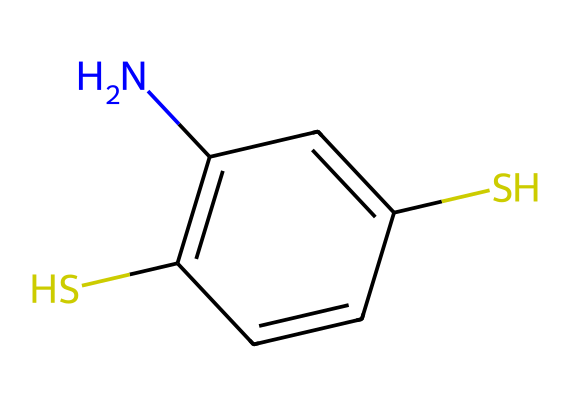what is the molecular formula of this compound? To determine the molecular formula, we count the number of each type of atom in the SMILES representation. In this case, there are 10 carbon (C) atoms, 9 hydrogen (H) atoms, 2 sulfur (S) atoms, and 1 nitrogen (N) atom. Therefore, the molecular formula is C10H9N2S2.
Answer: C10H9N2S2 how many sulfur atoms are present in this structure? By inspecting the SMILES notation, we see two instances of "S," which indicates the presence of two sulfur atoms in the structure. Thus, there are 2 sulfur atoms.
Answer: 2 what type of compounds are represented by this structure? The presence of sulfur atoms, along with the cyclic nature and specific functional groups in the structure, indicates that this compound belongs to the class of sulfur compounds.
Answer: sulfur compounds which atoms in the structure indicate the presence of a functional group? The nitrogen atom (N) in the structure is indicative of an amine functional group. In addition, the sulfur atoms (S) contribute to the properties associated with thiols or sulfides. Thus, the presence of both N and S highlights the functional groups.
Answer: nitrogen and sulfur how many double bonds can be found in this structure? Analyzing the SMILES, we can identify the double bonds as indicated by the "=" symbols. There are 3 double bonds present in the chemical structure.
Answer: 3 what role do sulfur atoms play in natural dyes derived from this compound? Sulfur atoms contribute to the vibrancy and stability of the color provided by the dye. They participate in the formation of thiol groups which can enhance the dyeing properties, influencing the bond with textile fibers.
Answer: stability and vibrancy what color is typically produced by dyes containing sulfur compounds like this? Dyes containing sulfur compounds can produce a range of colors, but they are particularly known for yielding rich shades of yellow, orange, or brown. This is owing to the specific structural arrangement and electronic properties of sulfur.
Answer: yellow, orange, or brown 